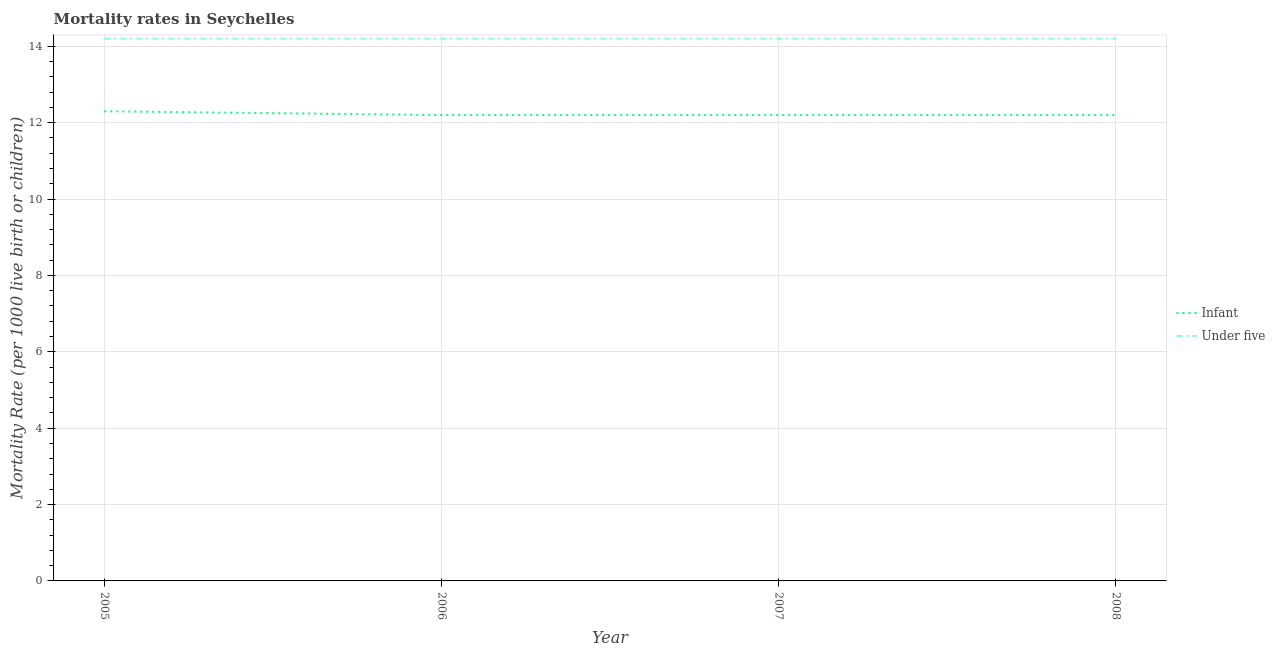Does the line corresponding to under-5 mortality rate intersect with the line corresponding to infant mortality rate?
Your response must be concise. No. Is the number of lines equal to the number of legend labels?
Your response must be concise. Yes. What is the under-5 mortality rate in 2005?
Your response must be concise. 14.2. Across all years, what is the minimum infant mortality rate?
Your response must be concise. 12.2. In which year was the infant mortality rate minimum?
Your answer should be compact. 2006. What is the total under-5 mortality rate in the graph?
Offer a very short reply. 56.8. What is the difference between the under-5 mortality rate in 2007 and the infant mortality rate in 2005?
Give a very brief answer. 1.9. What is the average under-5 mortality rate per year?
Your answer should be very brief. 14.2. In the year 2008, what is the difference between the infant mortality rate and under-5 mortality rate?
Offer a terse response. -2. In how many years, is the infant mortality rate greater than 7.6?
Offer a terse response. 4. Is the infant mortality rate in 2006 less than that in 2008?
Ensure brevity in your answer.  No. What is the difference between the highest and the second highest infant mortality rate?
Keep it short and to the point. 0.1. What is the difference between the highest and the lowest under-5 mortality rate?
Ensure brevity in your answer.  0. Is the under-5 mortality rate strictly greater than the infant mortality rate over the years?
Keep it short and to the point. Yes. Is the under-5 mortality rate strictly less than the infant mortality rate over the years?
Your answer should be compact. No. What is the difference between two consecutive major ticks on the Y-axis?
Your response must be concise. 2. Are the values on the major ticks of Y-axis written in scientific E-notation?
Offer a very short reply. No. Does the graph contain any zero values?
Your response must be concise. No. Does the graph contain grids?
Provide a short and direct response. Yes. Where does the legend appear in the graph?
Your answer should be compact. Center right. How many legend labels are there?
Keep it short and to the point. 2. What is the title of the graph?
Offer a very short reply. Mortality rates in Seychelles. Does "Lower secondary rate" appear as one of the legend labels in the graph?
Ensure brevity in your answer.  No. What is the label or title of the X-axis?
Keep it short and to the point. Year. What is the label or title of the Y-axis?
Your response must be concise. Mortality Rate (per 1000 live birth or children). Across all years, what is the maximum Mortality Rate (per 1000 live birth or children) in Infant?
Provide a short and direct response. 12.3. Across all years, what is the minimum Mortality Rate (per 1000 live birth or children) in Infant?
Ensure brevity in your answer.  12.2. Across all years, what is the minimum Mortality Rate (per 1000 live birth or children) in Under five?
Offer a very short reply. 14.2. What is the total Mortality Rate (per 1000 live birth or children) of Infant in the graph?
Offer a terse response. 48.9. What is the total Mortality Rate (per 1000 live birth or children) in Under five in the graph?
Your answer should be compact. 56.8. What is the difference between the Mortality Rate (per 1000 live birth or children) of Under five in 2005 and that in 2006?
Ensure brevity in your answer.  0. What is the difference between the Mortality Rate (per 1000 live birth or children) in Under five in 2005 and that in 2007?
Offer a terse response. 0. What is the difference between the Mortality Rate (per 1000 live birth or children) in Under five in 2005 and that in 2008?
Provide a short and direct response. 0. What is the difference between the Mortality Rate (per 1000 live birth or children) in Infant in 2006 and that in 2007?
Your answer should be very brief. 0. What is the difference between the Mortality Rate (per 1000 live birth or children) of Infant in 2006 and that in 2008?
Keep it short and to the point. 0. What is the difference between the Mortality Rate (per 1000 live birth or children) of Under five in 2006 and that in 2008?
Ensure brevity in your answer.  0. What is the difference between the Mortality Rate (per 1000 live birth or children) of Infant in 2007 and that in 2008?
Provide a succinct answer. 0. What is the difference between the Mortality Rate (per 1000 live birth or children) of Infant in 2005 and the Mortality Rate (per 1000 live birth or children) of Under five in 2007?
Provide a short and direct response. -1.9. What is the difference between the Mortality Rate (per 1000 live birth or children) of Infant in 2005 and the Mortality Rate (per 1000 live birth or children) of Under five in 2008?
Offer a very short reply. -1.9. What is the difference between the Mortality Rate (per 1000 live birth or children) of Infant in 2006 and the Mortality Rate (per 1000 live birth or children) of Under five in 2008?
Give a very brief answer. -2. What is the difference between the Mortality Rate (per 1000 live birth or children) in Infant in 2007 and the Mortality Rate (per 1000 live birth or children) in Under five in 2008?
Keep it short and to the point. -2. What is the average Mortality Rate (per 1000 live birth or children) of Infant per year?
Provide a succinct answer. 12.22. What is the average Mortality Rate (per 1000 live birth or children) in Under five per year?
Keep it short and to the point. 14.2. In the year 2005, what is the difference between the Mortality Rate (per 1000 live birth or children) of Infant and Mortality Rate (per 1000 live birth or children) of Under five?
Provide a succinct answer. -1.9. What is the ratio of the Mortality Rate (per 1000 live birth or children) of Infant in 2005 to that in 2006?
Ensure brevity in your answer.  1.01. What is the ratio of the Mortality Rate (per 1000 live birth or children) in Under five in 2005 to that in 2006?
Provide a short and direct response. 1. What is the ratio of the Mortality Rate (per 1000 live birth or children) in Infant in 2005 to that in 2007?
Your answer should be very brief. 1.01. What is the ratio of the Mortality Rate (per 1000 live birth or children) of Under five in 2005 to that in 2007?
Offer a very short reply. 1. What is the ratio of the Mortality Rate (per 1000 live birth or children) of Infant in 2005 to that in 2008?
Provide a succinct answer. 1.01. What is the ratio of the Mortality Rate (per 1000 live birth or children) in Under five in 2005 to that in 2008?
Offer a terse response. 1. What is the ratio of the Mortality Rate (per 1000 live birth or children) in Infant in 2006 to that in 2007?
Provide a succinct answer. 1. What is the ratio of the Mortality Rate (per 1000 live birth or children) in Under five in 2006 to that in 2007?
Give a very brief answer. 1. What is the ratio of the Mortality Rate (per 1000 live birth or children) of Under five in 2006 to that in 2008?
Your answer should be compact. 1. What is the difference between the highest and the second highest Mortality Rate (per 1000 live birth or children) of Infant?
Your answer should be very brief. 0.1. What is the difference between the highest and the lowest Mortality Rate (per 1000 live birth or children) of Under five?
Offer a terse response. 0. 